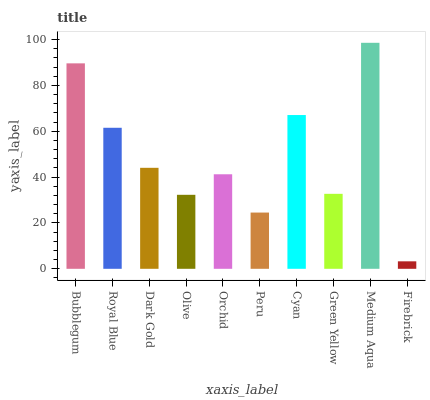Is Firebrick the minimum?
Answer yes or no. Yes. Is Medium Aqua the maximum?
Answer yes or no. Yes. Is Royal Blue the minimum?
Answer yes or no. No. Is Royal Blue the maximum?
Answer yes or no. No. Is Bubblegum greater than Royal Blue?
Answer yes or no. Yes. Is Royal Blue less than Bubblegum?
Answer yes or no. Yes. Is Royal Blue greater than Bubblegum?
Answer yes or no. No. Is Bubblegum less than Royal Blue?
Answer yes or no. No. Is Dark Gold the high median?
Answer yes or no. Yes. Is Orchid the low median?
Answer yes or no. Yes. Is Royal Blue the high median?
Answer yes or no. No. Is Firebrick the low median?
Answer yes or no. No. 